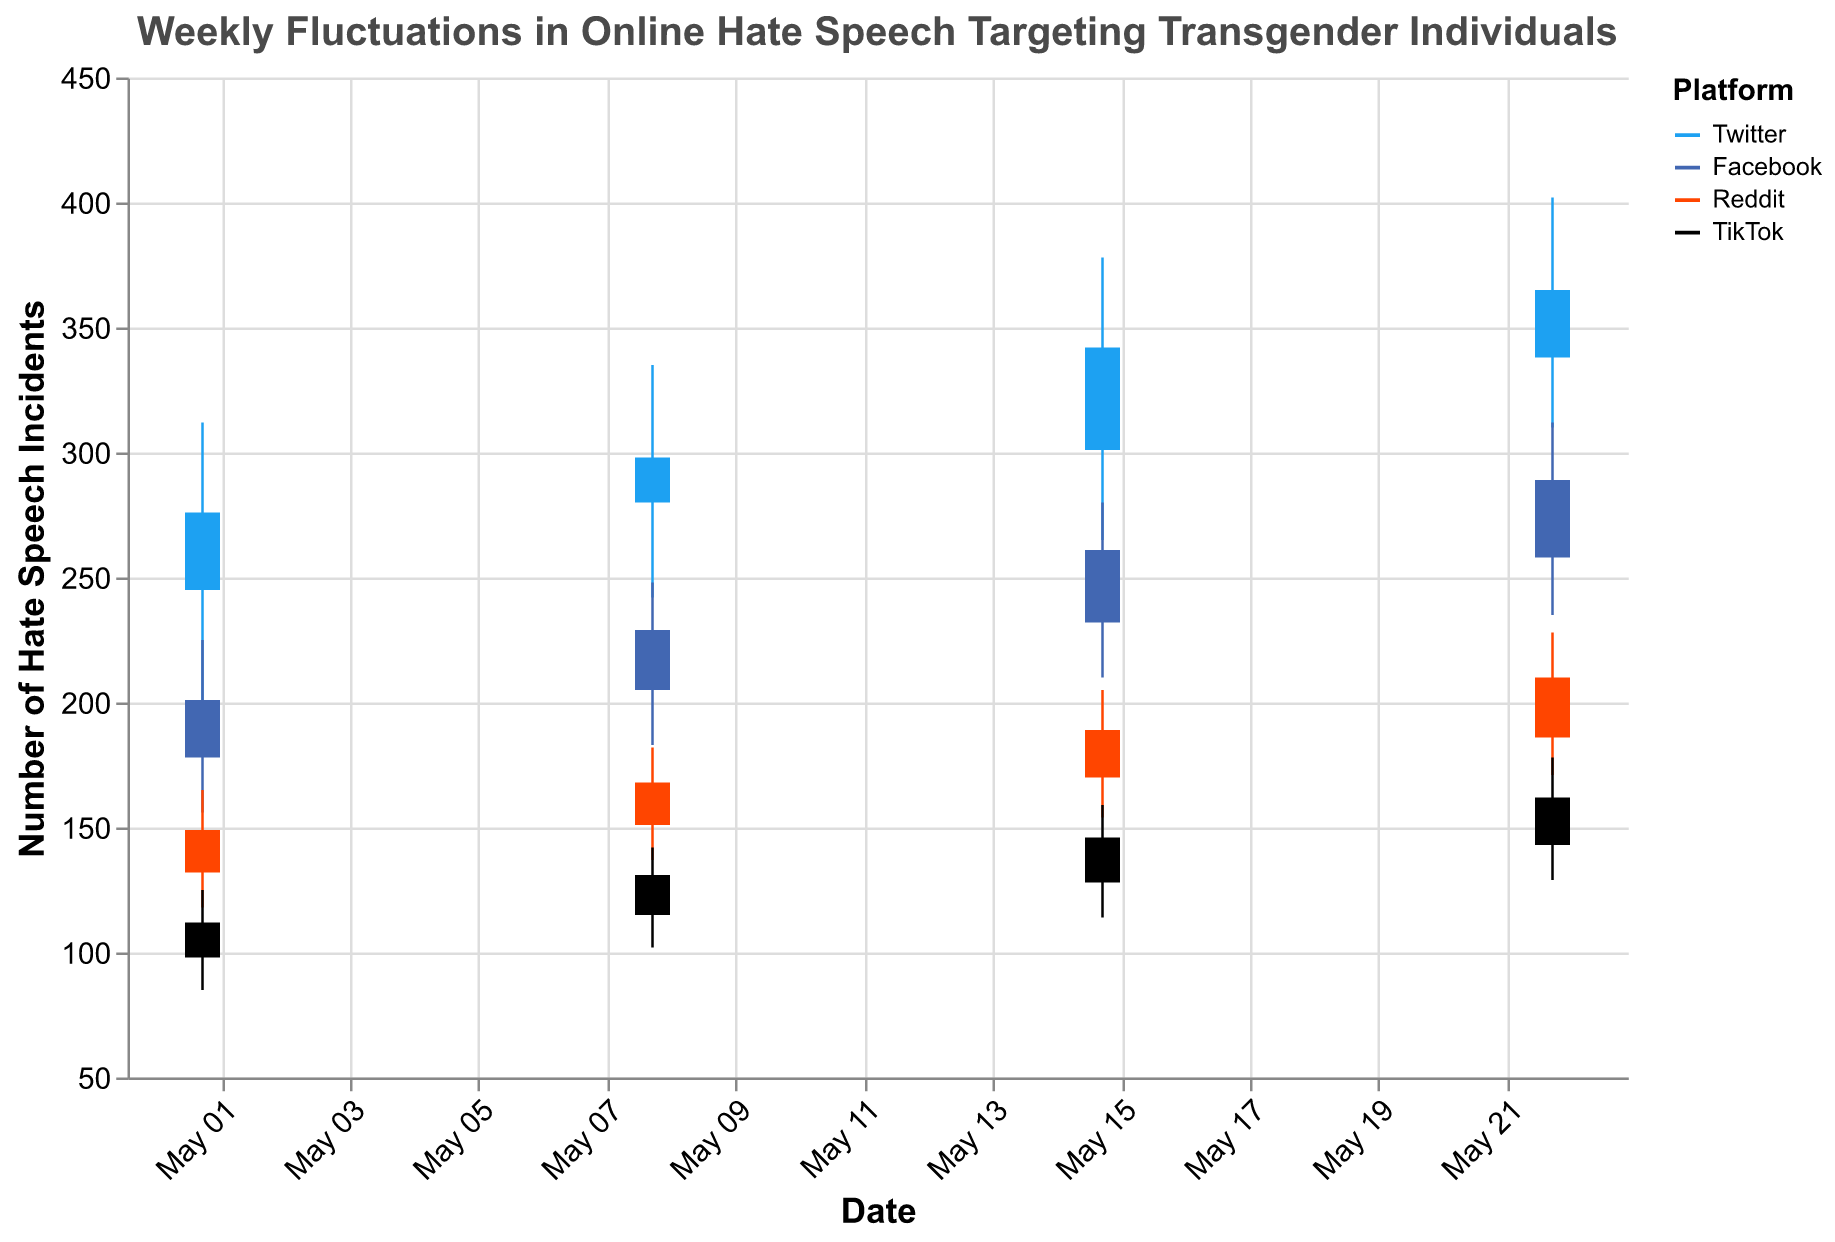What is the title of the figure? The title of the figure can be found at the top of the chart. It reads "Weekly Fluctuations in Online Hate Speech Targeting Transgender Individuals".
Answer: Weekly Fluctuations in Online Hate Speech Targeting Transgender Individuals Which platform had the highest number of hate speech incidents in the week of May 22, 2023? On May 22, 2023, look at the highest 'High' values for each platform. Twitter has the highest 'High' value at 402.
Answer: Twitter What is the range of hate speech incidents for Facebook in the week of May 08, 2023? For May 08, 2023, the range can be calculated as 'High' - 'Low' for Facebook. The values are High = 248 and Low = 183, so the range is 248 - 183 = 65.
Answer: 65 Which platform had the most consistent level of hate speech incidents (smallest difference between High and Low) on May 15, 2023? For May 15, 2023, find the difference between 'High' and 'Low' for each platform. The differences are: Twitter = 113, Facebook = 70, Reddit = 51, TikTok = 45. The smallest difference is for TikTok.
Answer: TikTok On which date did Reddit experience the largest increase in the number of hate speech incidents at the close compared to the previous week? Compare the 'Close' values of Reddit from week to week: 149 (May 01), 168 (May 08), 189 (May 15), 210 (May 22). The largest increase is from May 15 to May 22 (210 - 189 = 21).
Answer: May 22, 2023 Which platform shows a consistent upward trend in the number of hate speech incidents across all weeks? By observing the 'Close' values for each platform across the weeks, TikTok consistently has increasing values: 112, 131, 146, 162.
Answer: TikTok How many platforms are represented in the figure? Count the unique platforms in the legend. There are four platforms: Twitter, Facebook, Reddit, and TikTok.
Answer: 4 What is the low value for Twitter on May 01, 2023, and how does it compare to the low value for Reddit on the same date? On May 01, 2023, Twitter's 'Low' value is 198, and Reddit's 'Low' value is 118. The difference is 198 - 118 = 80.
Answer: 80 What was the opening value for Facebook on May 15, 2023? For May 15, 2023, the 'Open' value for Facebook is given directly as 232.
Answer: 232 